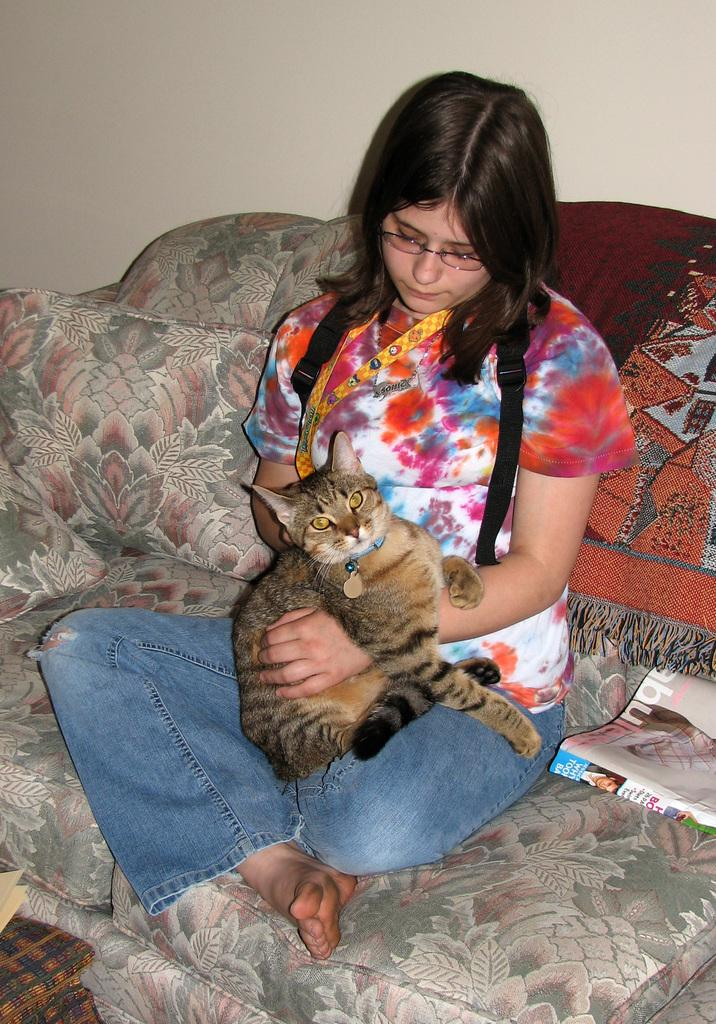Who is present in the image? There is a woman in the image. What is the woman doing in the image? The woman is holding a cat in her lap. Where is the woman sitting in the image? The woman is sitting on a sofa. What can be seen in the background of the image? There is a wall in the background of the image. What type of head can be seen in the image? There is no head visible in the image; it features a woman holding a cat in her lap while sitting on a sofa. 